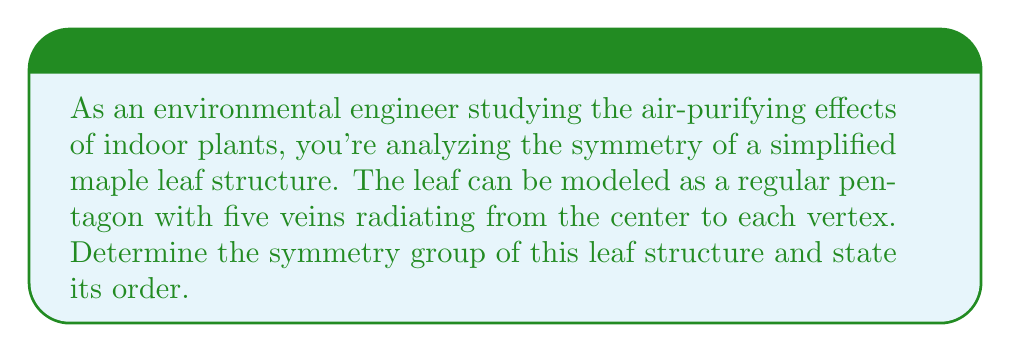Show me your answer to this math problem. To determine the symmetry group of the leaf structure, we need to consider all the symmetry operations that leave the shape unchanged. For a regular pentagon with radial veins, we have:

1. Rotational symmetries:
   - Identity rotation (0°)
   - Rotations of 72°, 144°, 216°, and 288°

2. Reflection symmetries:
   - 5 lines of reflection, each passing through a vertex and the midpoint of the opposite side

Let's analyze these symmetries:

a) Rotations form a cyclic subgroup of order 5, which we can denote as $C_5$.

b) Reflections, when combined with rotations, generate the dihedral group of order 10, denoted as $D_5$.

The dihedral group $D_5$ includes all the symmetries of a regular pentagon:
$$D_5 = \{e, r, r^2, r^3, r^4, s, sr, sr^2, sr^3, sr^4\}$$

Where:
- $e$ is the identity element
- $r$ represents a rotation of 72°
- $s$ represents a reflection

The group operation table for $D_5$ would be a 10x10 matrix, showing how these elements combine.

To verify that this is indeed a group:
1. Closure: All combinations of rotations and reflections result in elements within the set.
2. Associativity: Matrix multiplication (which these operations represent) is associative.
3. Identity: The identity rotation $e$ serves as the identity element.
4. Inverse: Each element has an inverse (e.g., $r^{-1} = r^4$, $s^{-1} = s$).

Therefore, the symmetry group of the leaf structure is the dihedral group $D_5$.

The order of the group is the number of elements, which is 10.
Answer: The symmetry group of the leaf structure is the dihedral group $D_5$, with order 10. 